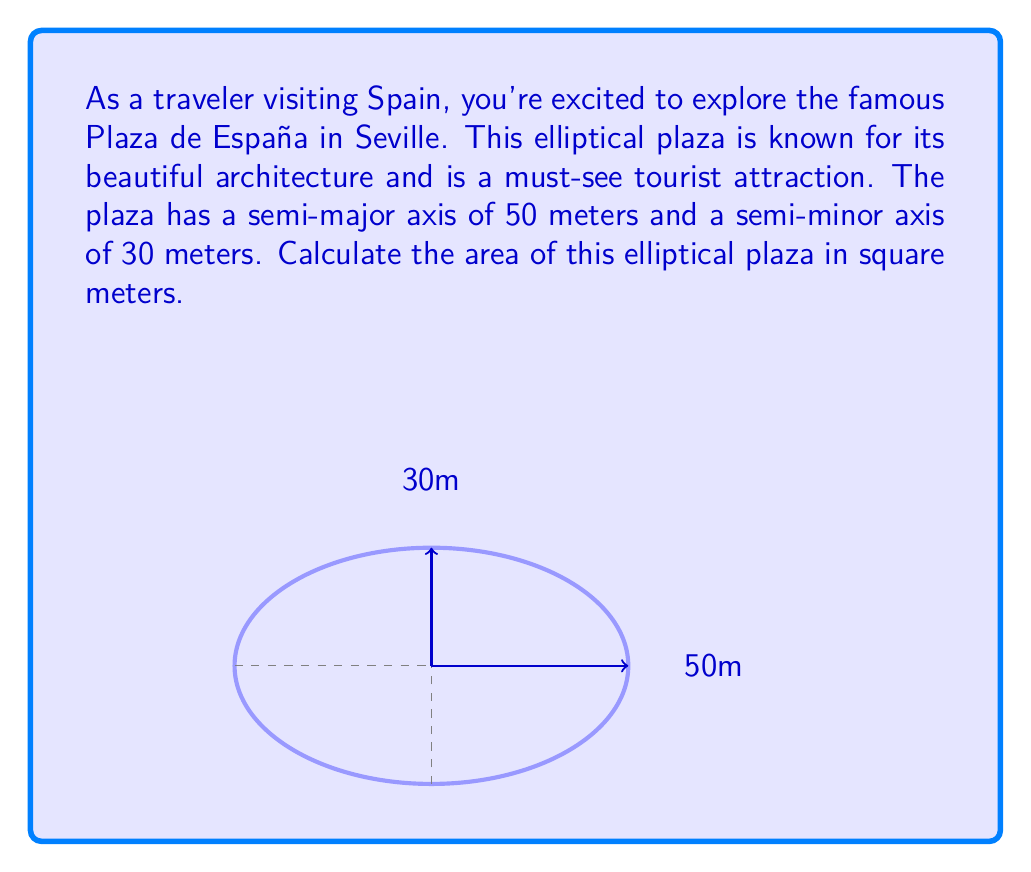Provide a solution to this math problem. To calculate the area of an elliptical plaza, we need to use the formula for the area of an ellipse:

$$A = \pi ab$$

Where:
$A$ is the area of the ellipse
$a$ is the length of the semi-major axis
$b$ is the length of the semi-minor axis
$\pi$ is approximately 3.14159

Given:
- Semi-major axis (a) = 50 meters
- Semi-minor axis (b) = 30 meters

Let's substitute these values into the formula:

$$A = \pi \cdot 50 \cdot 30$$

Now, let's calculate:

$$A = 3.14159 \cdot 50 \cdot 30$$
$$A = 4712.385 \text{ square meters}$$

Rounding to the nearest whole number:

$$A \approx 4712 \text{ square meters}$$

Therefore, the area of the elliptical Plaza de España in Seville is approximately 4712 square meters.
Answer: 4712 m² 